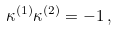Convert formula to latex. <formula><loc_0><loc_0><loc_500><loc_500>\kappa ^ { ( 1 ) } \kappa ^ { ( 2 ) } = - 1 \, ,</formula> 